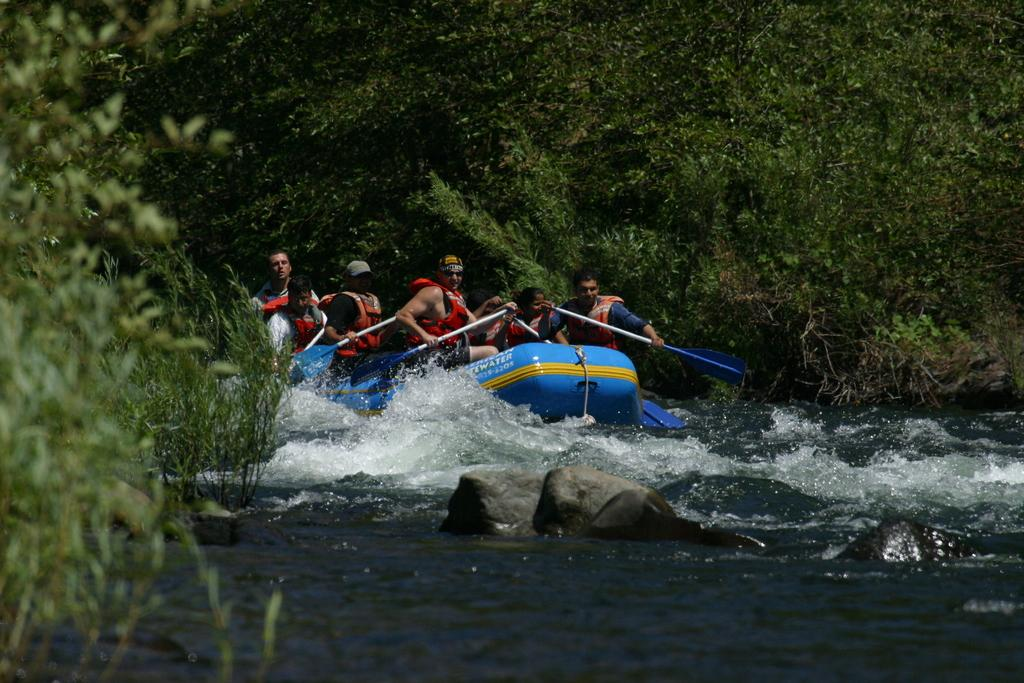What type of natural vegetation can be seen in the image? There are trees in the image. What are the people holding in the image? The people are holding paddles in the image. What mode of transportation is present in the image? There is a boat in the image. What is the primary setting of the image? There is water visible in the image. What type of terrain can be seen in the image? There are stones in the image. What type of bag can be seen hanging from the trees in the image? There is no bag hanging from the trees in the image. What type of shock can be seen affecting the people holding paddles in the image? There is no shock affecting the people holding paddles in the image. What type of arm is visible in the image? There is no specific arm mentioned or visible in the image. 